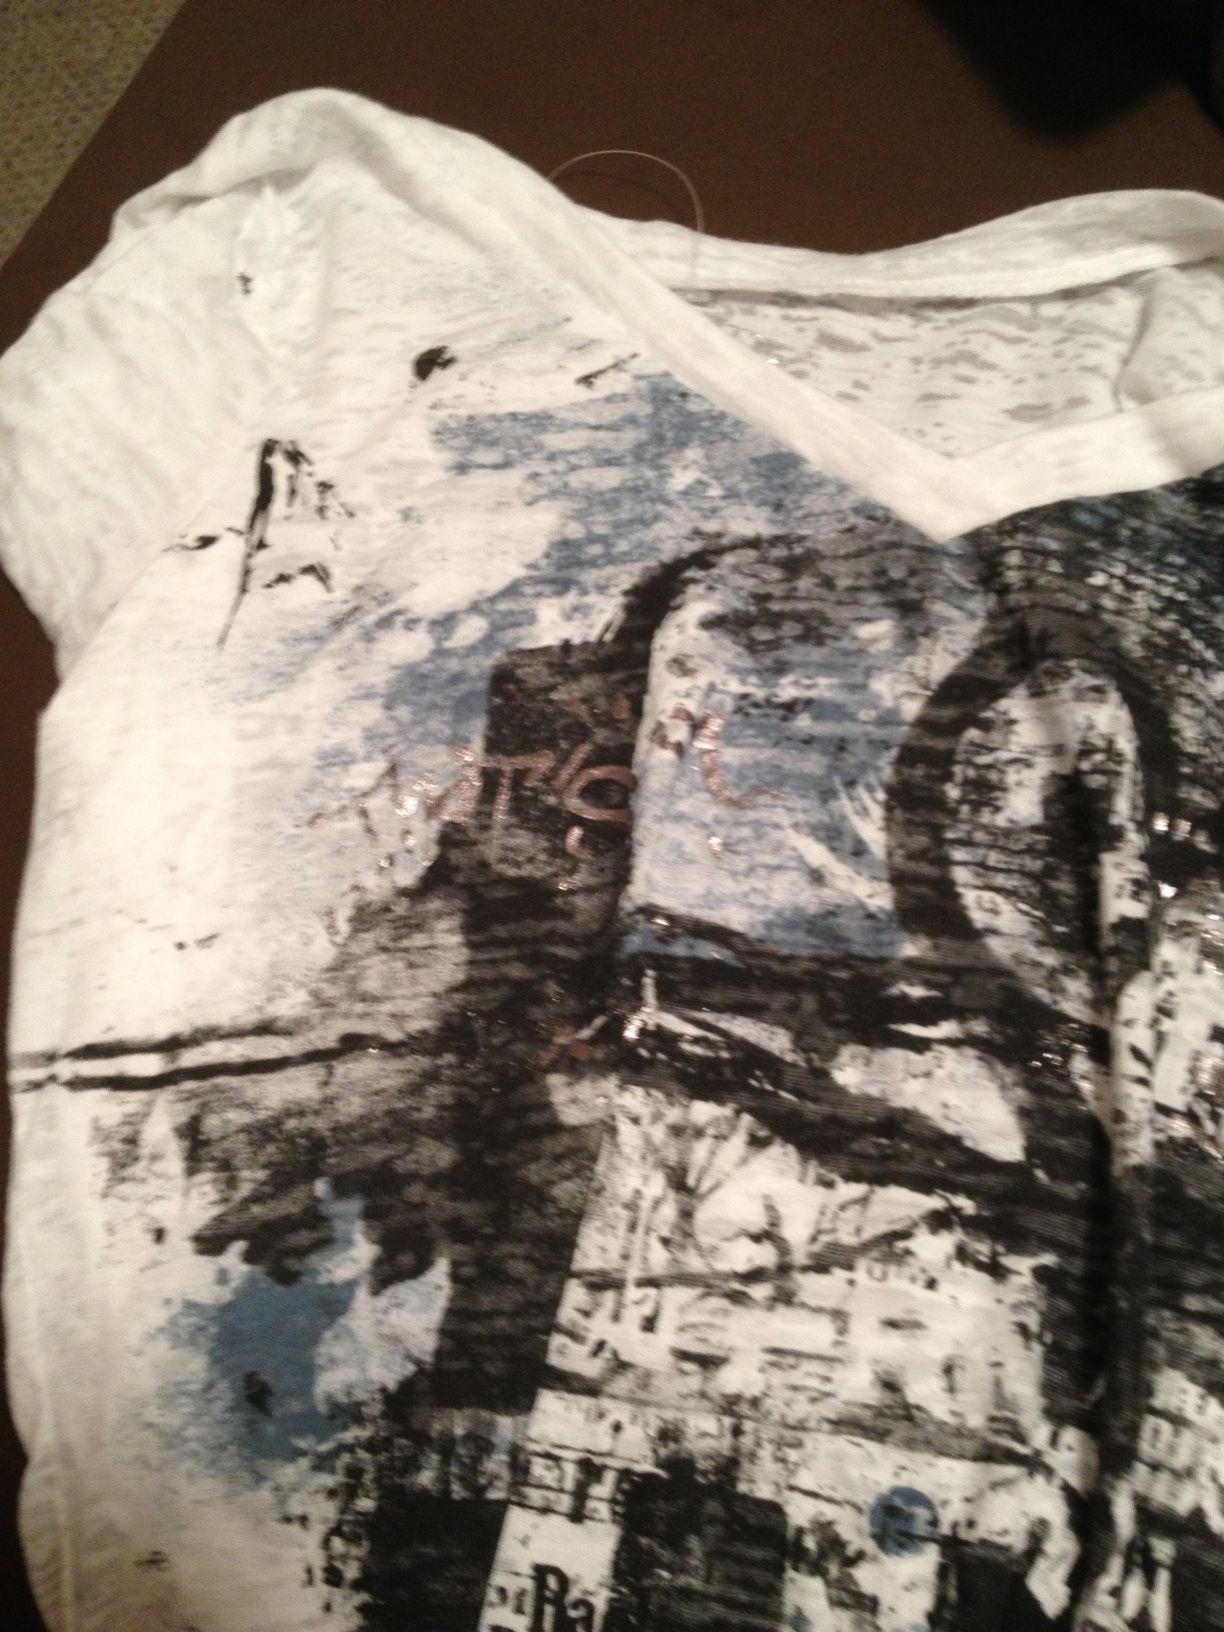If the design on this shirt had a sound or music associated with it, what would it be? The sound or music associated with this design would likely be an experimental piece, featuring a mix of electronic sounds, ambient noises, and irregular beats. It might include sudden bursts of energy contrasting with softer, slower segments, mirroring the dynamic and contrasting elements of the design. The composition would be unpredictable, yet cohesive, creating an atmospheric experience that captures the abstract essence of the artwork. 